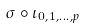<formula> <loc_0><loc_0><loc_500><loc_500>\sigma \circ \iota _ { 0 , 1 , \dots , p }</formula> 